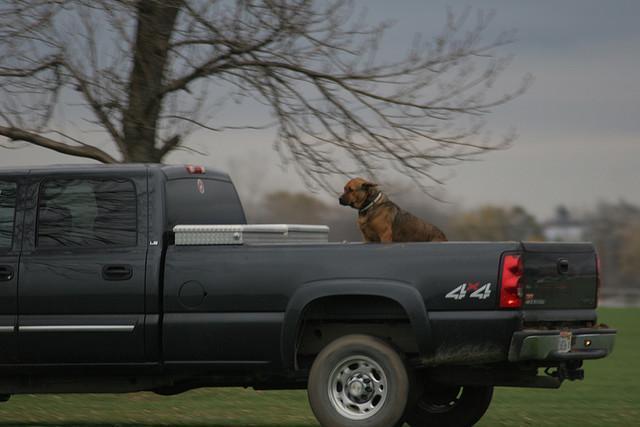How many squid-shaped kites can be seen?
Give a very brief answer. 0. 